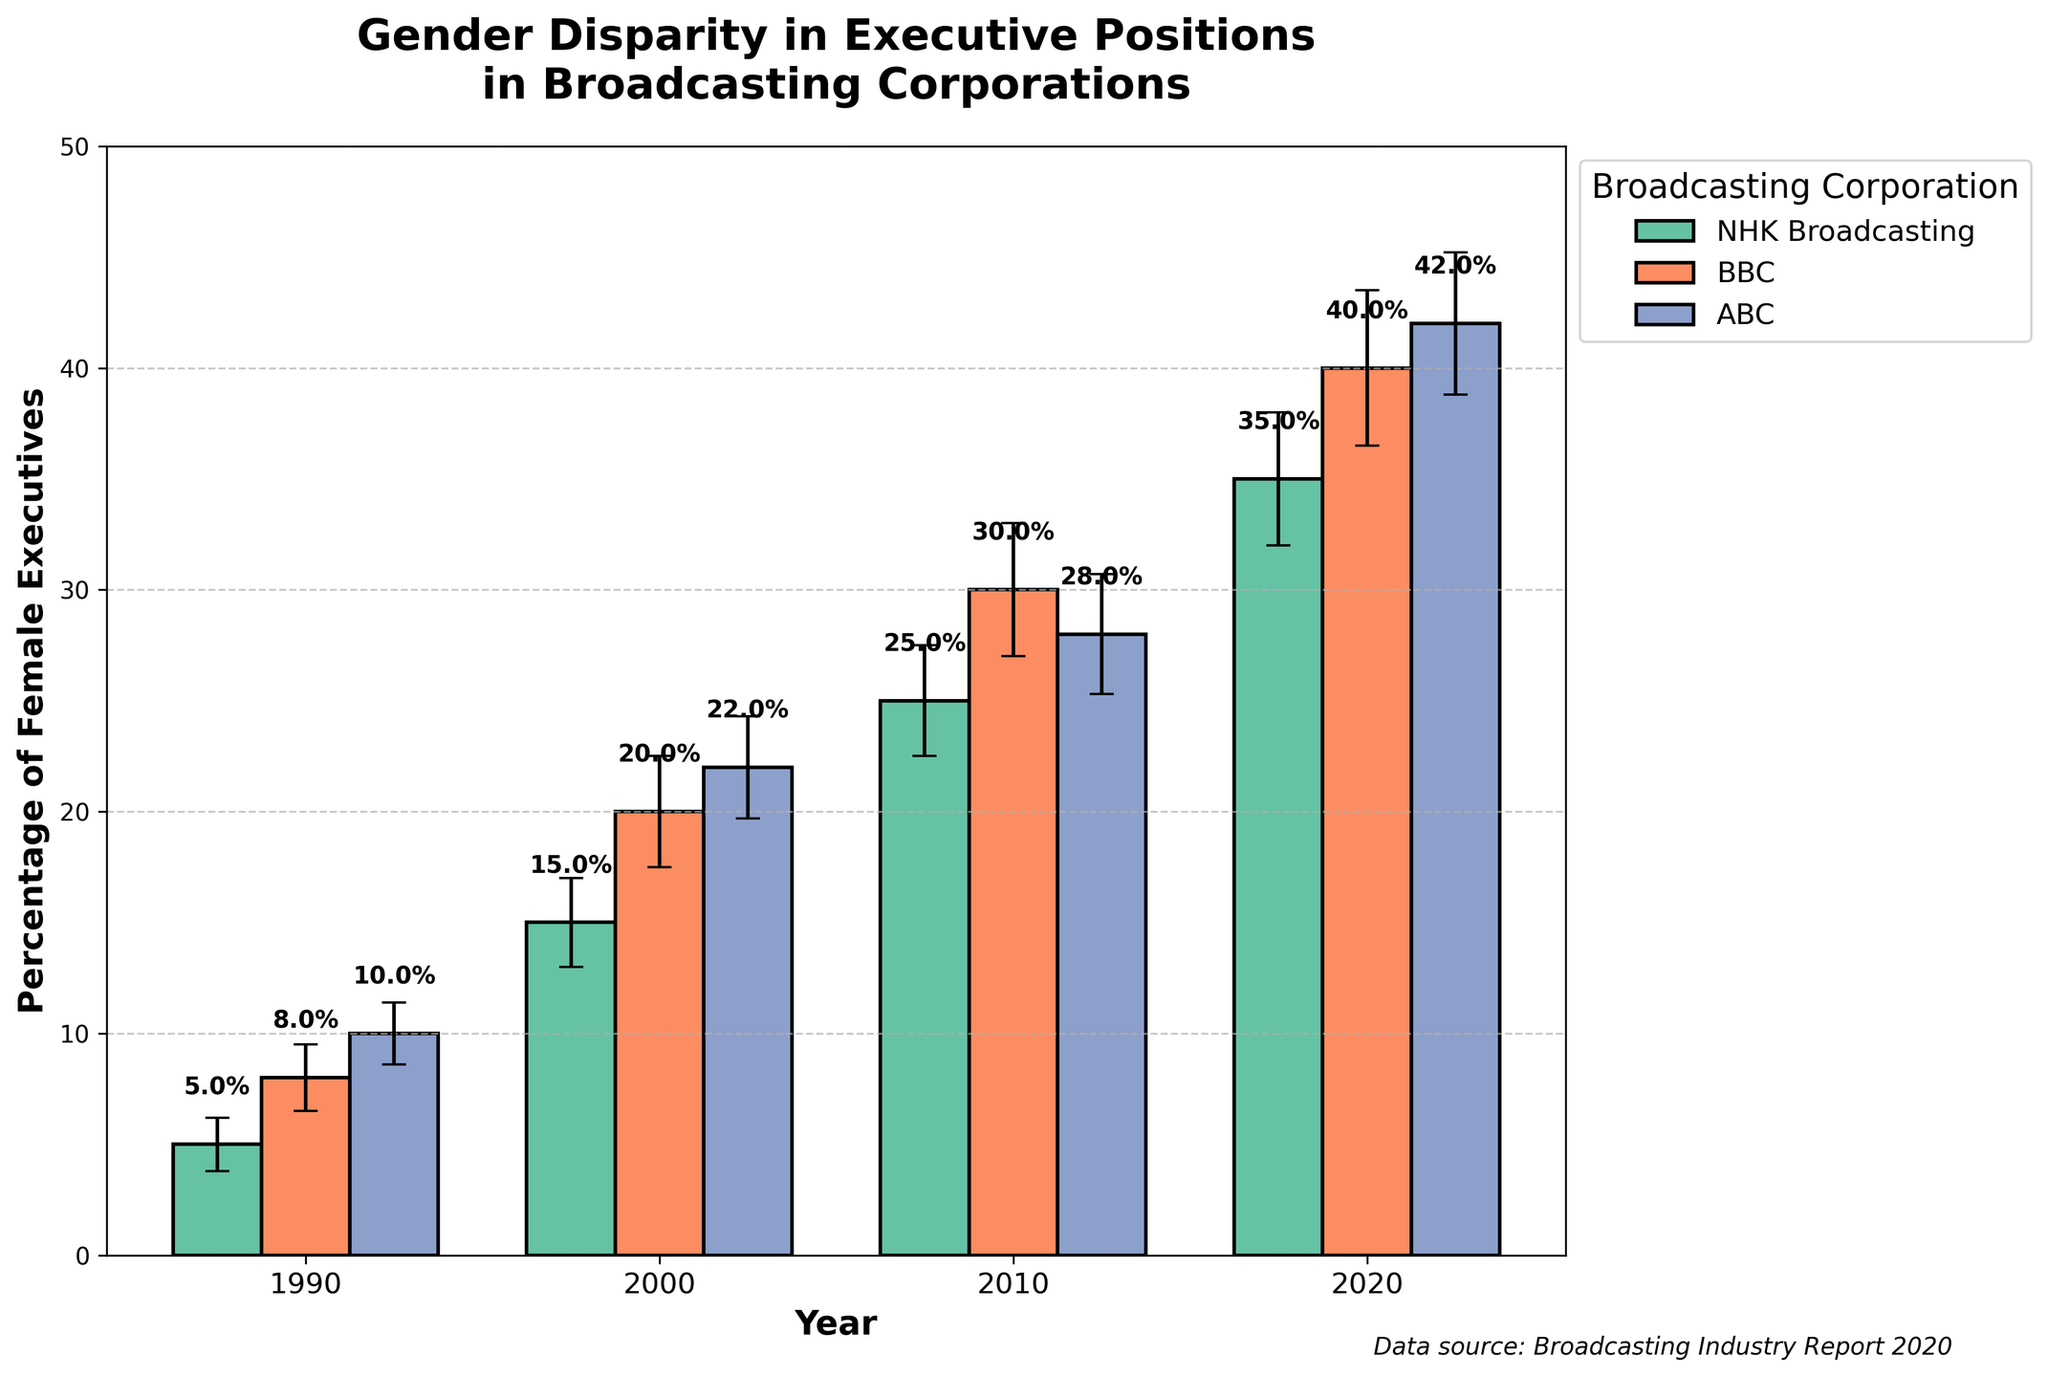What's the title of the figure? The title is usually located at the top of the figure and provides a brief description of the chart's content.
Answer: Gender Disparity in Executive Positions in Broadcasting Corporations What is the percentage of female executives at NHK Broadcasting in 2020? Locate the bar for NHK Broadcasting in the year 2020 and read the percentage value directly from the top of the bar.
Answer: 35% Which corporation had the highest percentage of female executives in 2010? Compare the heights of all the bars for the year 2010 and find the corporation with the tallest bar.
Answer: BBC Between NHK Broadcasting and ABC, which corporation showed a greater increase in the percentage of female executives from 1990 to 2020? Determine the percentage increase for both corporations by subtracting the 1990 value from the 2020 value, and compare these differences.
Answer: ABC What’s the average percentage of female executives across all corporations in 2000? Add the percentages of female executives for all corporations in the year 2000 and divide by the number of corporations (3).
Answer: 19% Considering error bars, which corporation showed the greatest uncertainty in the percentage of female executives in 2020? Compare the lengths of the error bars for each corporation in 2020 and identify the one with the longest error bar.
Answer: BBC What is the general trend in the percentage of female executives at NHK Broadcasting from 1990 to 2020? Observe the bars corresponding to NHK Broadcasting for each year and describe the overall direction of change.
Answer: Increasing How does the percentage of female executives at ABC in 2020 compare to that in 1990? Subtract the percentage of female executives at ABC in 1990 from that in 2020 to determine the increase.
Answer: Increased by 32% Which corporation had the smallest change in the percentage of female executives from 1990 to 2010? Calculate the percentage change for each corporation and identify the one with the smallest difference.
Answer: NHK Broadcasting 